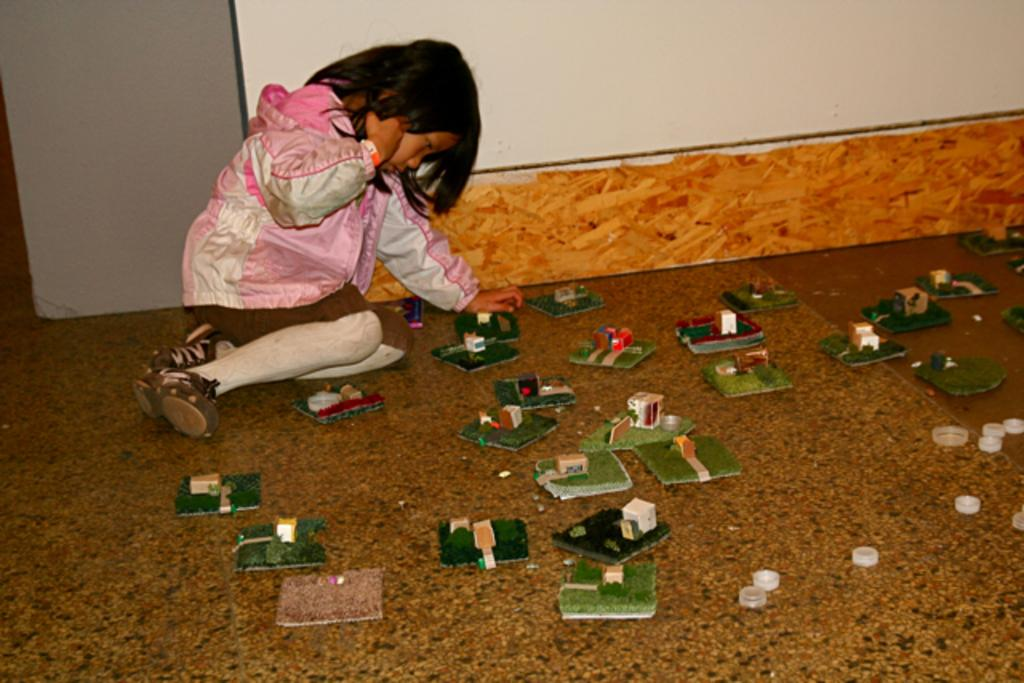What is the girl in the image doing? The girl is sitting on the floor in the image. What can be seen on the floor in the image? There are things placed on the floor in the image. What is visible in the background of the image? There is a wall in the background of the image. What advice is the person giving to the girl in the image? There is no person present in the image to give advice to the girl. 